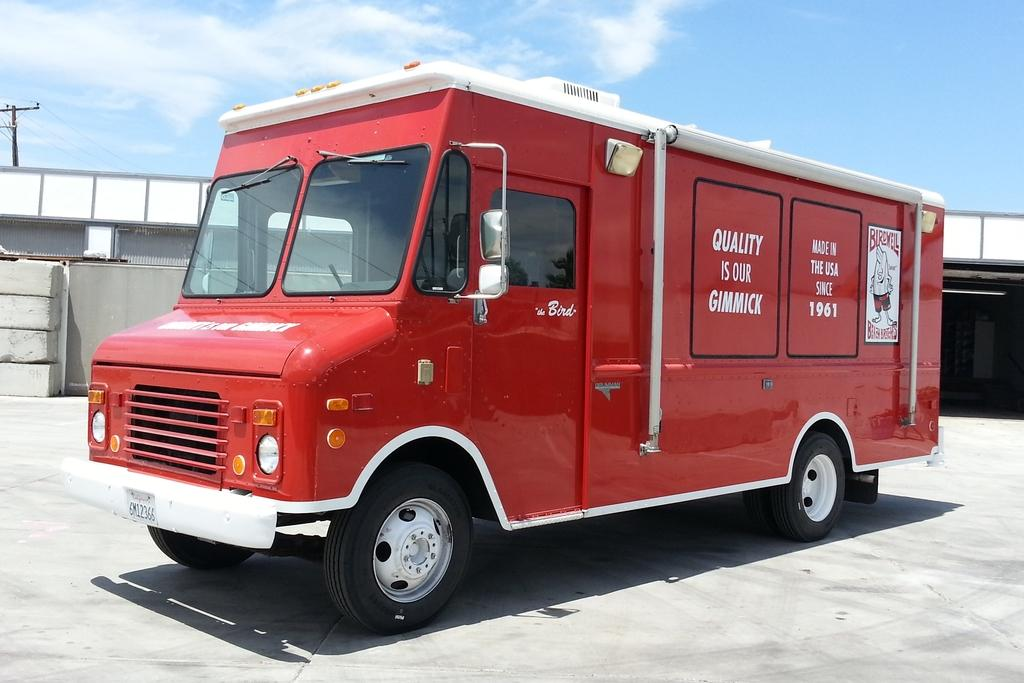What is the main subject of the image? There is a red color van in the middle of the image. What can be seen in the background of the image? There are buildings, bricks, and a pole in the background of the image. What is the condition of the sky in the image? Clouds are visible in the image. What type of peace symbol can be seen on the van in the image? There is no peace symbol present on the van in the image. What type of lettuce is growing in the background of the image? There is no lettuce present in the image. 